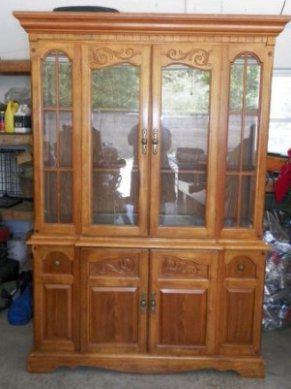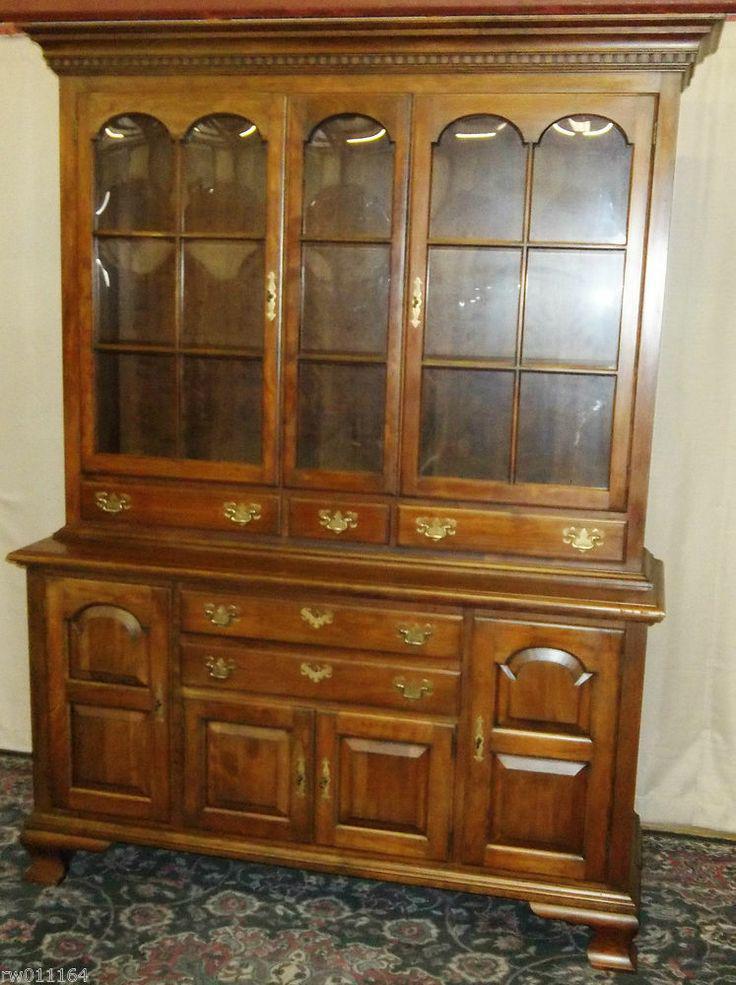The first image is the image on the left, the second image is the image on the right. Examine the images to the left and right. Is the description "At least one of the cabinets has no legs and sits flush on the floor." accurate? Answer yes or no. No. The first image is the image on the left, the second image is the image on the right. Evaluate the accuracy of this statement regarding the images: "There are three vertically stacked drawers in the image on the left.". Is it true? Answer yes or no. No. 